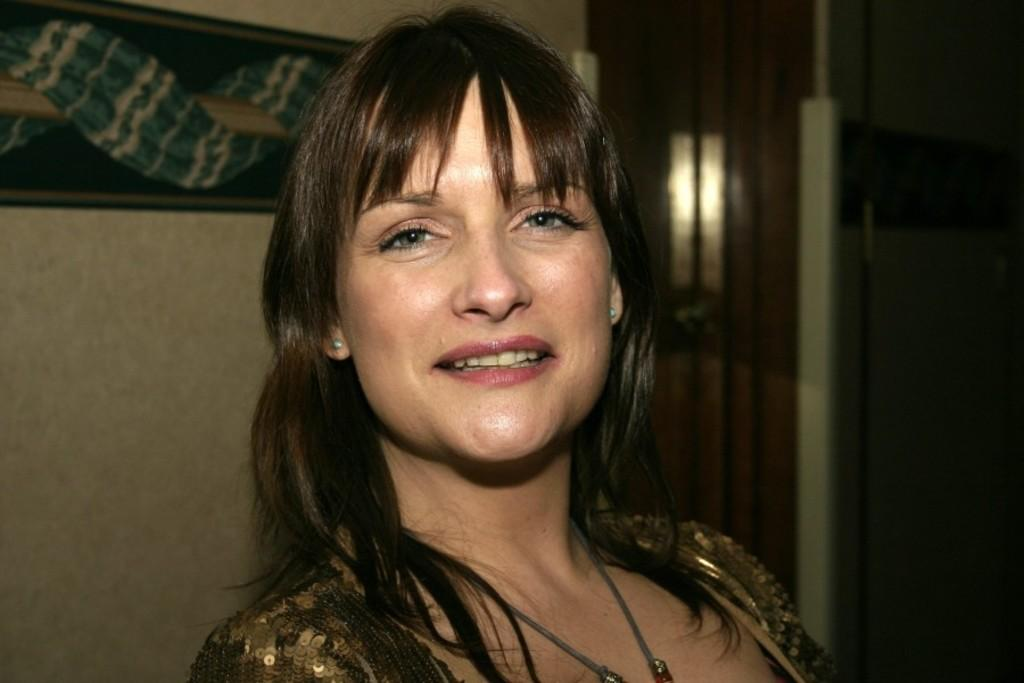Who is present in the image? There is a woman in the image. What is the woman's facial expression? The woman is smiling. What can be seen in the background of the image? There is a wall in the background of the image. What type of owl can be seen flying in the image? There is no owl present in the image; it only features a woman and a wall in the background. 